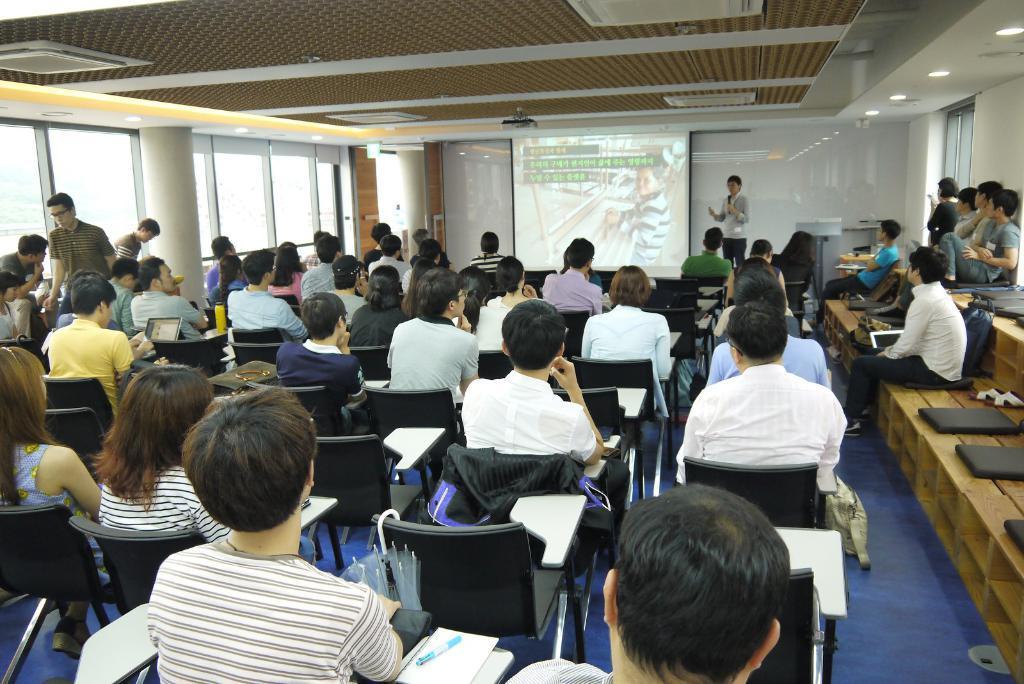Describe this image in one or two sentences. This picture might be taken in the classroom. In this image, on the right side, we can see a group of people sitting on the bench. On that bench, we can see few laptops, bags. In the middle of the image, we can see a group of people sitting on the chair, on that chair, we can see a book and a pen. In the background, we can see a person standing and holding a microphone and a screen. On the left side, we can see a pillar and a glass window. At the top, we can see a roof with few lights, at the bottom, we can see a mat which is in blue color. 